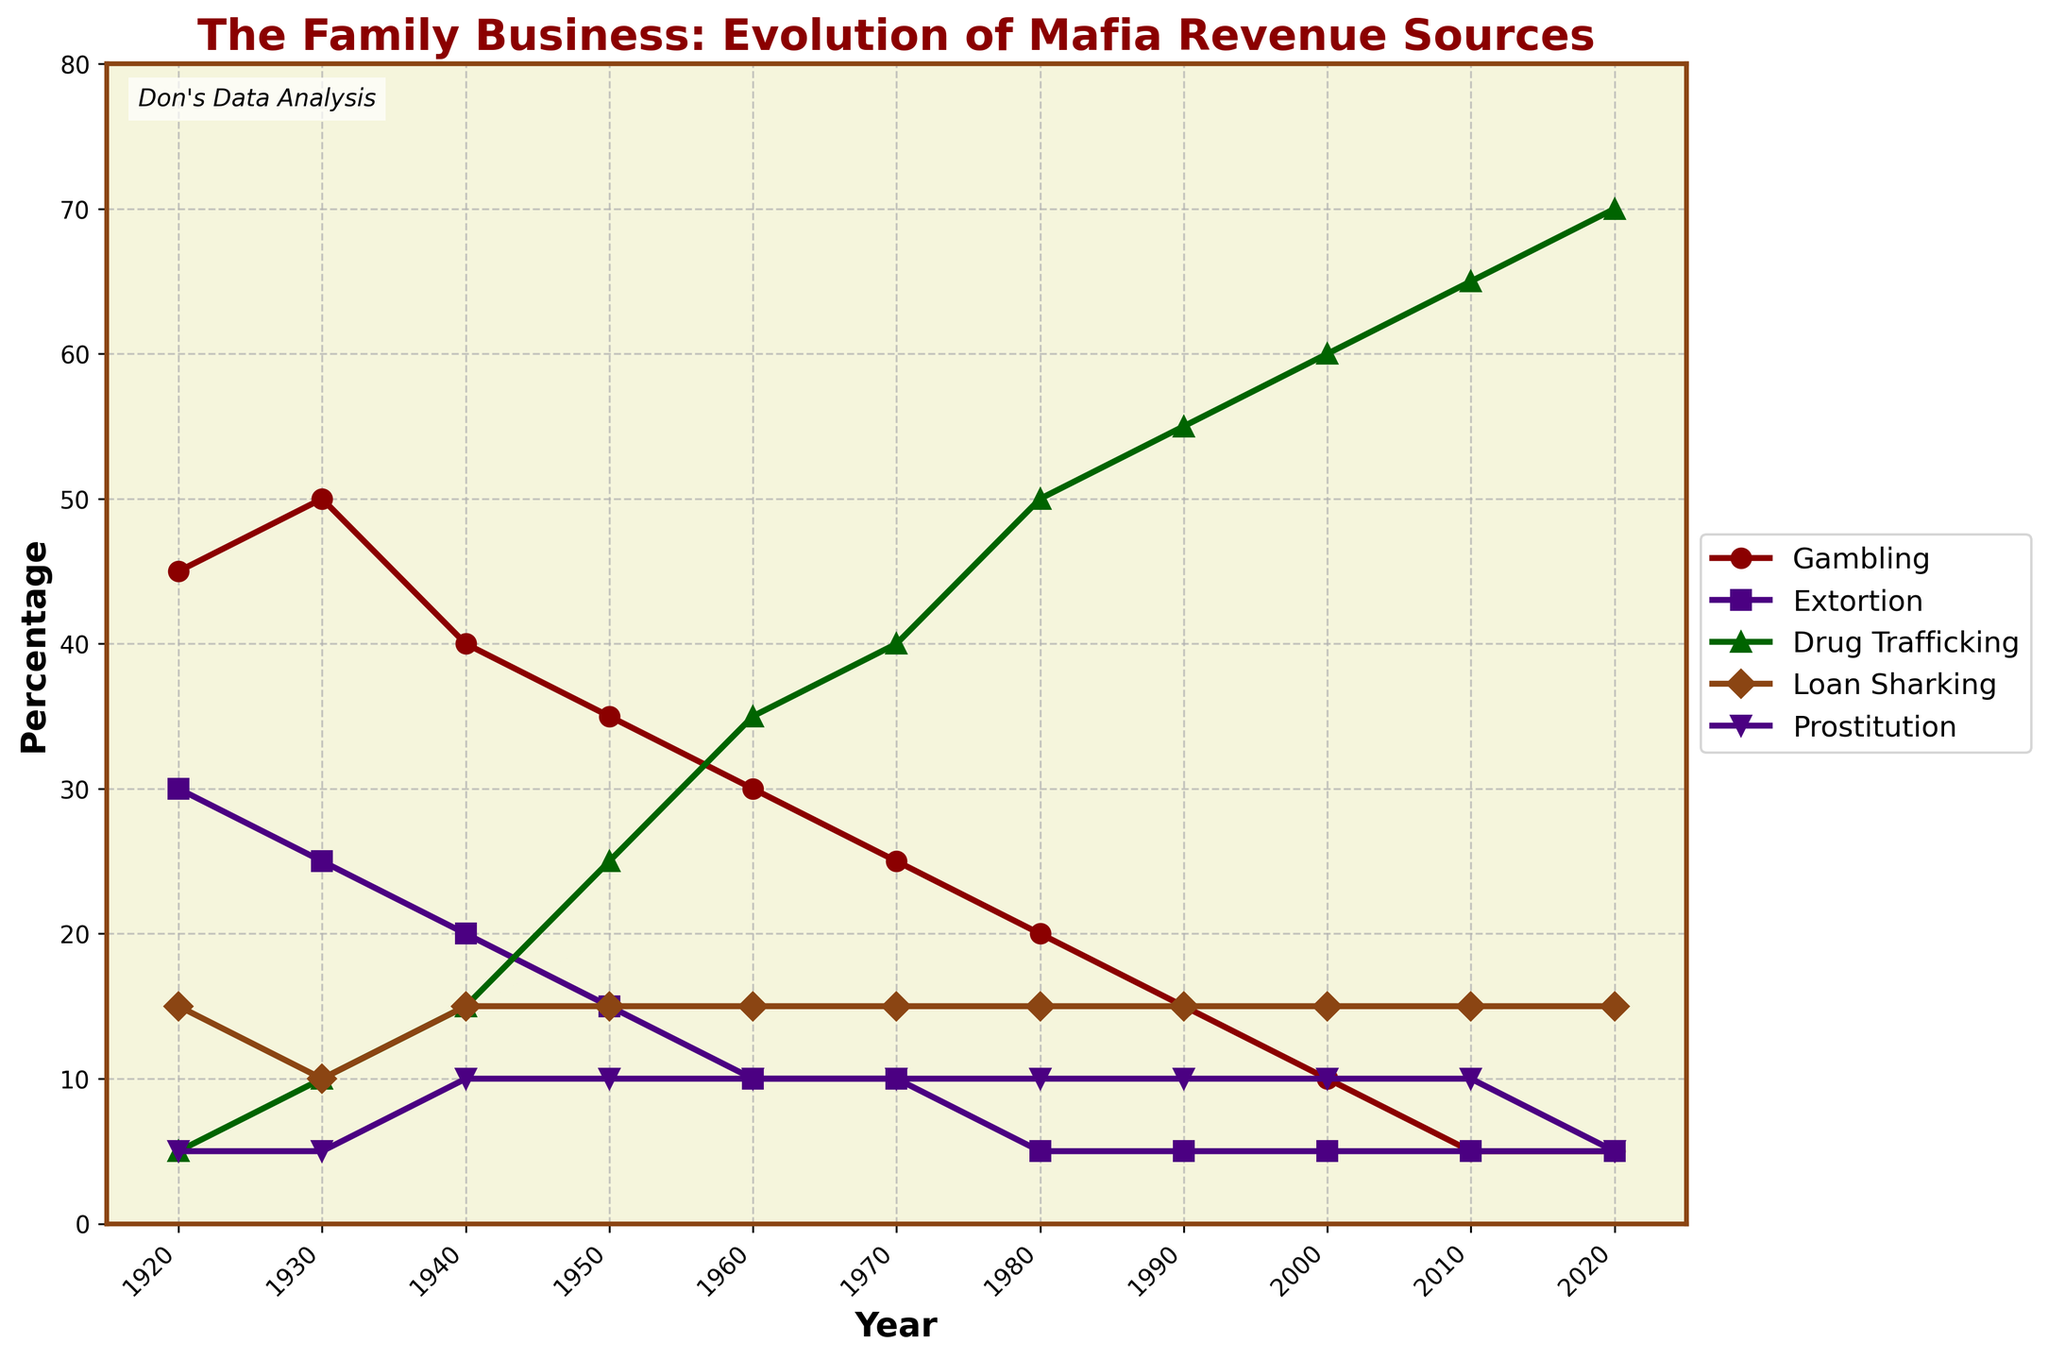Which revenue source experiences the most significant growth from 1920 to 2020? Examine the chart and trace the lines, noting the percentage change over the years. Drug trafficking increases significantly from 5% in 1920 to 70% in 2020.
Answer: Drug trafficking Which year did gambling revenue start to decline more sharply compared to the previous trends? Observe the line representing gambling revenue. While it declines consistently, the drop becomes more pronounced around the 1950s (35%) compared to previous years.
Answer: 1950 How much did extortion's contribution change from 1920 to 2010? Measure the difference in the percentage values for extortion between 1920 and 2010. The value decreases from 30% to 5%, resulting in a 25% decline.
Answer: 25% Between 1920 and 2020, during which decade does drug trafficking surpass gambling in revenue for the first time? Compare the lines for drug trafficking and gambling decade by decade. Drug trafficking exceeds gambling for the first time in the 1950s.
Answer: 1950s Which revenue source remains unchanged the most over the years? Check the lines for each revenue source, looking for the most stable one. Prostitution stays consistent at 5-10% throughout the timeline.
Answer: Prostitution In what year are gambling, extortion, and drug trafficking all at their lowest points simultaneously? Identify the year where the values for all three sources reach their minima. In 2020, gambling (5%), extortion (5%), and drug trafficking each have their lowest values.
Answer: 2020 What is the average percentage for loan sharking from 1920 to 2020? Compute the average by summing the percentage values for each given year and dividing by the number of years. The total is 140%, so the average is 140/10 = 14%.
Answer: 14% Between which two decades does drug trafficking show the steepest increase? Follow the line representing drug trafficking and observe the steepness of the incline. The sharpest rise occurs between the 1970s and 1980s, increasing from 40% to 50%.
Answer: 1970-1980 How has the revenue from gambling and extortion evolved differently over the years? Trace both lines on the chart. Gambling starts high at 45% and declines steadily to 5%. Extortion starts at 30%, reduces faster, and also ends at 5%. The main difference is that gambling declines gradually whereas extortion declines quickly in the earlier decades.
Answer: Gambling declines gradually; extortion declines quickly and then stabilizes Considering all revenue sources, which source exhibits the highest peak percentage, and in which year? Look at the highest point reached by any revenue source line on the chart. Drug trafficking reaches its peak at 70% in 2020.
Answer: Drug trafficking, 2020 